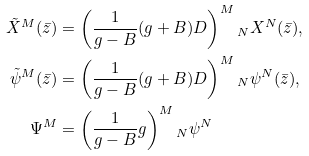<formula> <loc_0><loc_0><loc_500><loc_500>\tilde { X } ^ { M } ( \bar { z } ) & = \left ( \frac { 1 } { g - B } ( g + B ) D \right ) ^ { M } { _ { N } } X ^ { N } ( \bar { z } ) , \\ \tilde { \psi } ^ { M } ( \bar { z } ) & = \left ( \frac { 1 } { g - B } ( g + B ) D \right ) ^ { M } { _ { N } } \psi ^ { N } ( \bar { z } ) , \\ \Psi ^ { M } & = \left ( \frac { 1 } { g - B } g \right ) ^ { M } { _ { N } } \psi ^ { N }</formula> 